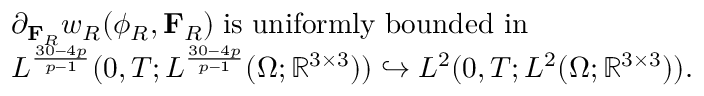<formula> <loc_0><loc_0><loc_500><loc_500>\begin{array} { r l } & { \partial _ { F _ { R } } w _ { R } ( \phi _ { R } , F _ { R } ) \, i s u n i f o r m l y b o u n d e d i n \, } \\ & { L ^ { \frac { 3 0 - 4 p } { p - 1 } } ( 0 , T ; L ^ { \frac { 3 0 - 4 p } { p - 1 } } ( \Omega ; \mathbb { R } ^ { 3 \times 3 } ) ) \hookrightarrow L ^ { 2 } ( 0 , T ; L ^ { 2 } ( \Omega ; \mathbb { R } ^ { 3 \times 3 } ) ) . } \end{array}</formula> 